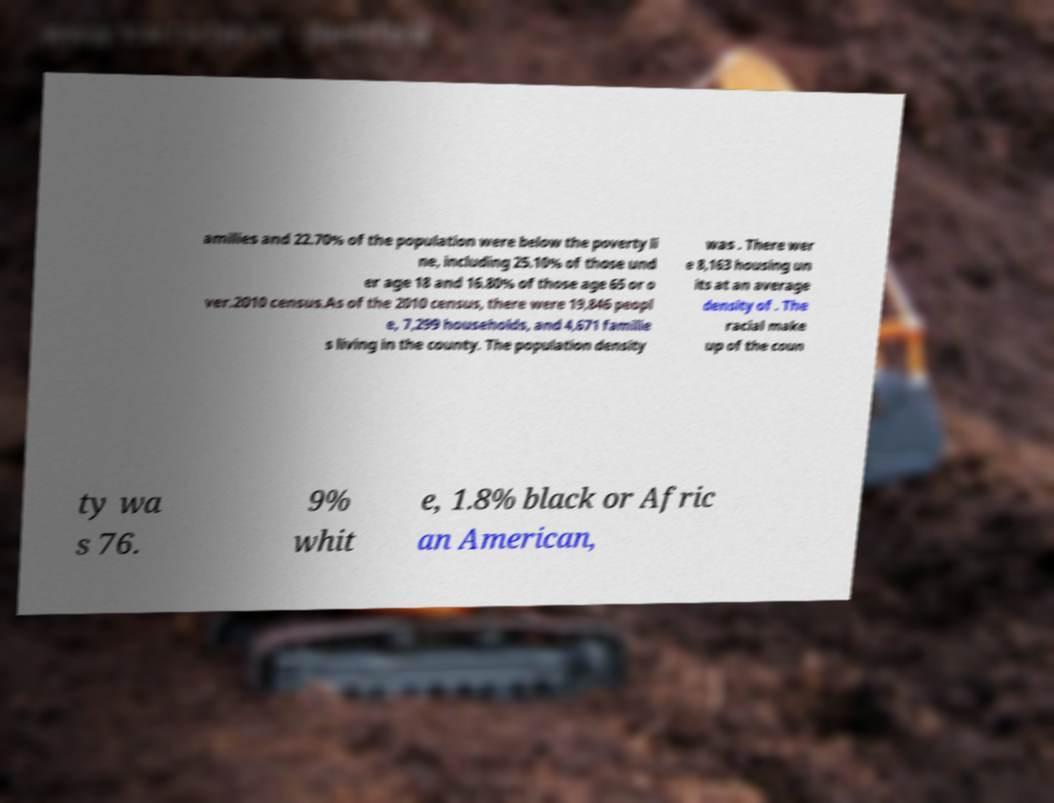What messages or text are displayed in this image? I need them in a readable, typed format. amilies and 22.70% of the population were below the poverty li ne, including 25.10% of those und er age 18 and 16.80% of those age 65 or o ver.2010 census.As of the 2010 census, there were 19,846 peopl e, 7,299 households, and 4,671 familie s living in the county. The population density was . There wer e 8,163 housing un its at an average density of . The racial make up of the coun ty wa s 76. 9% whit e, 1.8% black or Afric an American, 